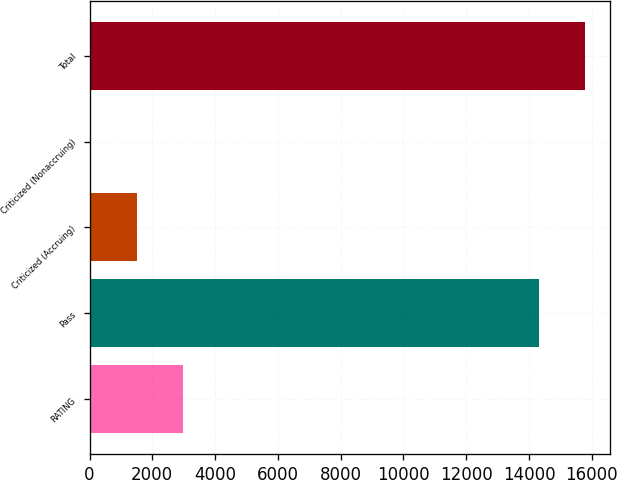<chart> <loc_0><loc_0><loc_500><loc_500><bar_chart><fcel>RATING<fcel>Pass<fcel>Criticized (Accruing)<fcel>Criticized (Nonaccruing)<fcel>Total<nl><fcel>2978.6<fcel>14308<fcel>1502.3<fcel>26<fcel>15784.3<nl></chart> 